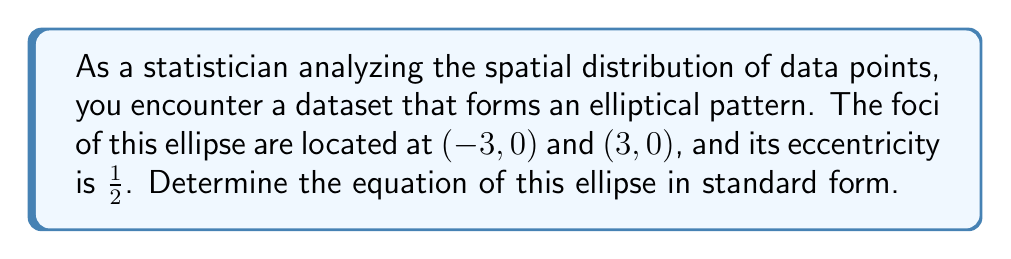Could you help me with this problem? Let's approach this step-by-step:

1) The standard form of an ellipse with center at the origin is:

   $$\frac{x^2}{a^2} + \frac{y^2}{b^2} = 1$$

   where $a$ is the length of the semi-major axis and $b$ is the length of the semi-minor axis.

2) The distance between the foci is $2c$. Here, the foci are at $(-3, 0)$ and $(3, 0)$, so:

   $2c = 6$
   $c = 3$

3) The eccentricity $e$ is given by $e = \frac{c}{a}$. We're told that $e = \frac{1}{2}$, so:

   $$\frac{1}{2} = \frac{3}{a}$$

4) Solving for $a$:

   $a = 6$

5) Now we can use the relation $a^2 = b^2 + c^2$ to find $b$:

   $6^2 = b^2 + 3^2$
   $36 = b^2 + 9$
   $b^2 = 27$
   $b = 3\sqrt{3}$

6) Now we have all the components to write the equation in standard form:

   $$\frac{x^2}{a^2} + \frac{y^2}{b^2} = 1$$
   $$\frac{x^2}{36} + \frac{y^2}{27} = 1$$

7) To simplify, multiply both sides by 108 (the LCM of 36 and 27):

   $$3x^2 + 4y^2 = 108$$
Answer: The equation of the ellipse in standard form is:

$$3x^2 + 4y^2 = 108$$ 